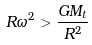Convert formula to latex. <formula><loc_0><loc_0><loc_500><loc_500>R \omega ^ { 2 } > \frac { G M _ { t } } { R ^ { 2 } }</formula> 